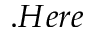<formula> <loc_0><loc_0><loc_500><loc_500>. H e r e</formula> 